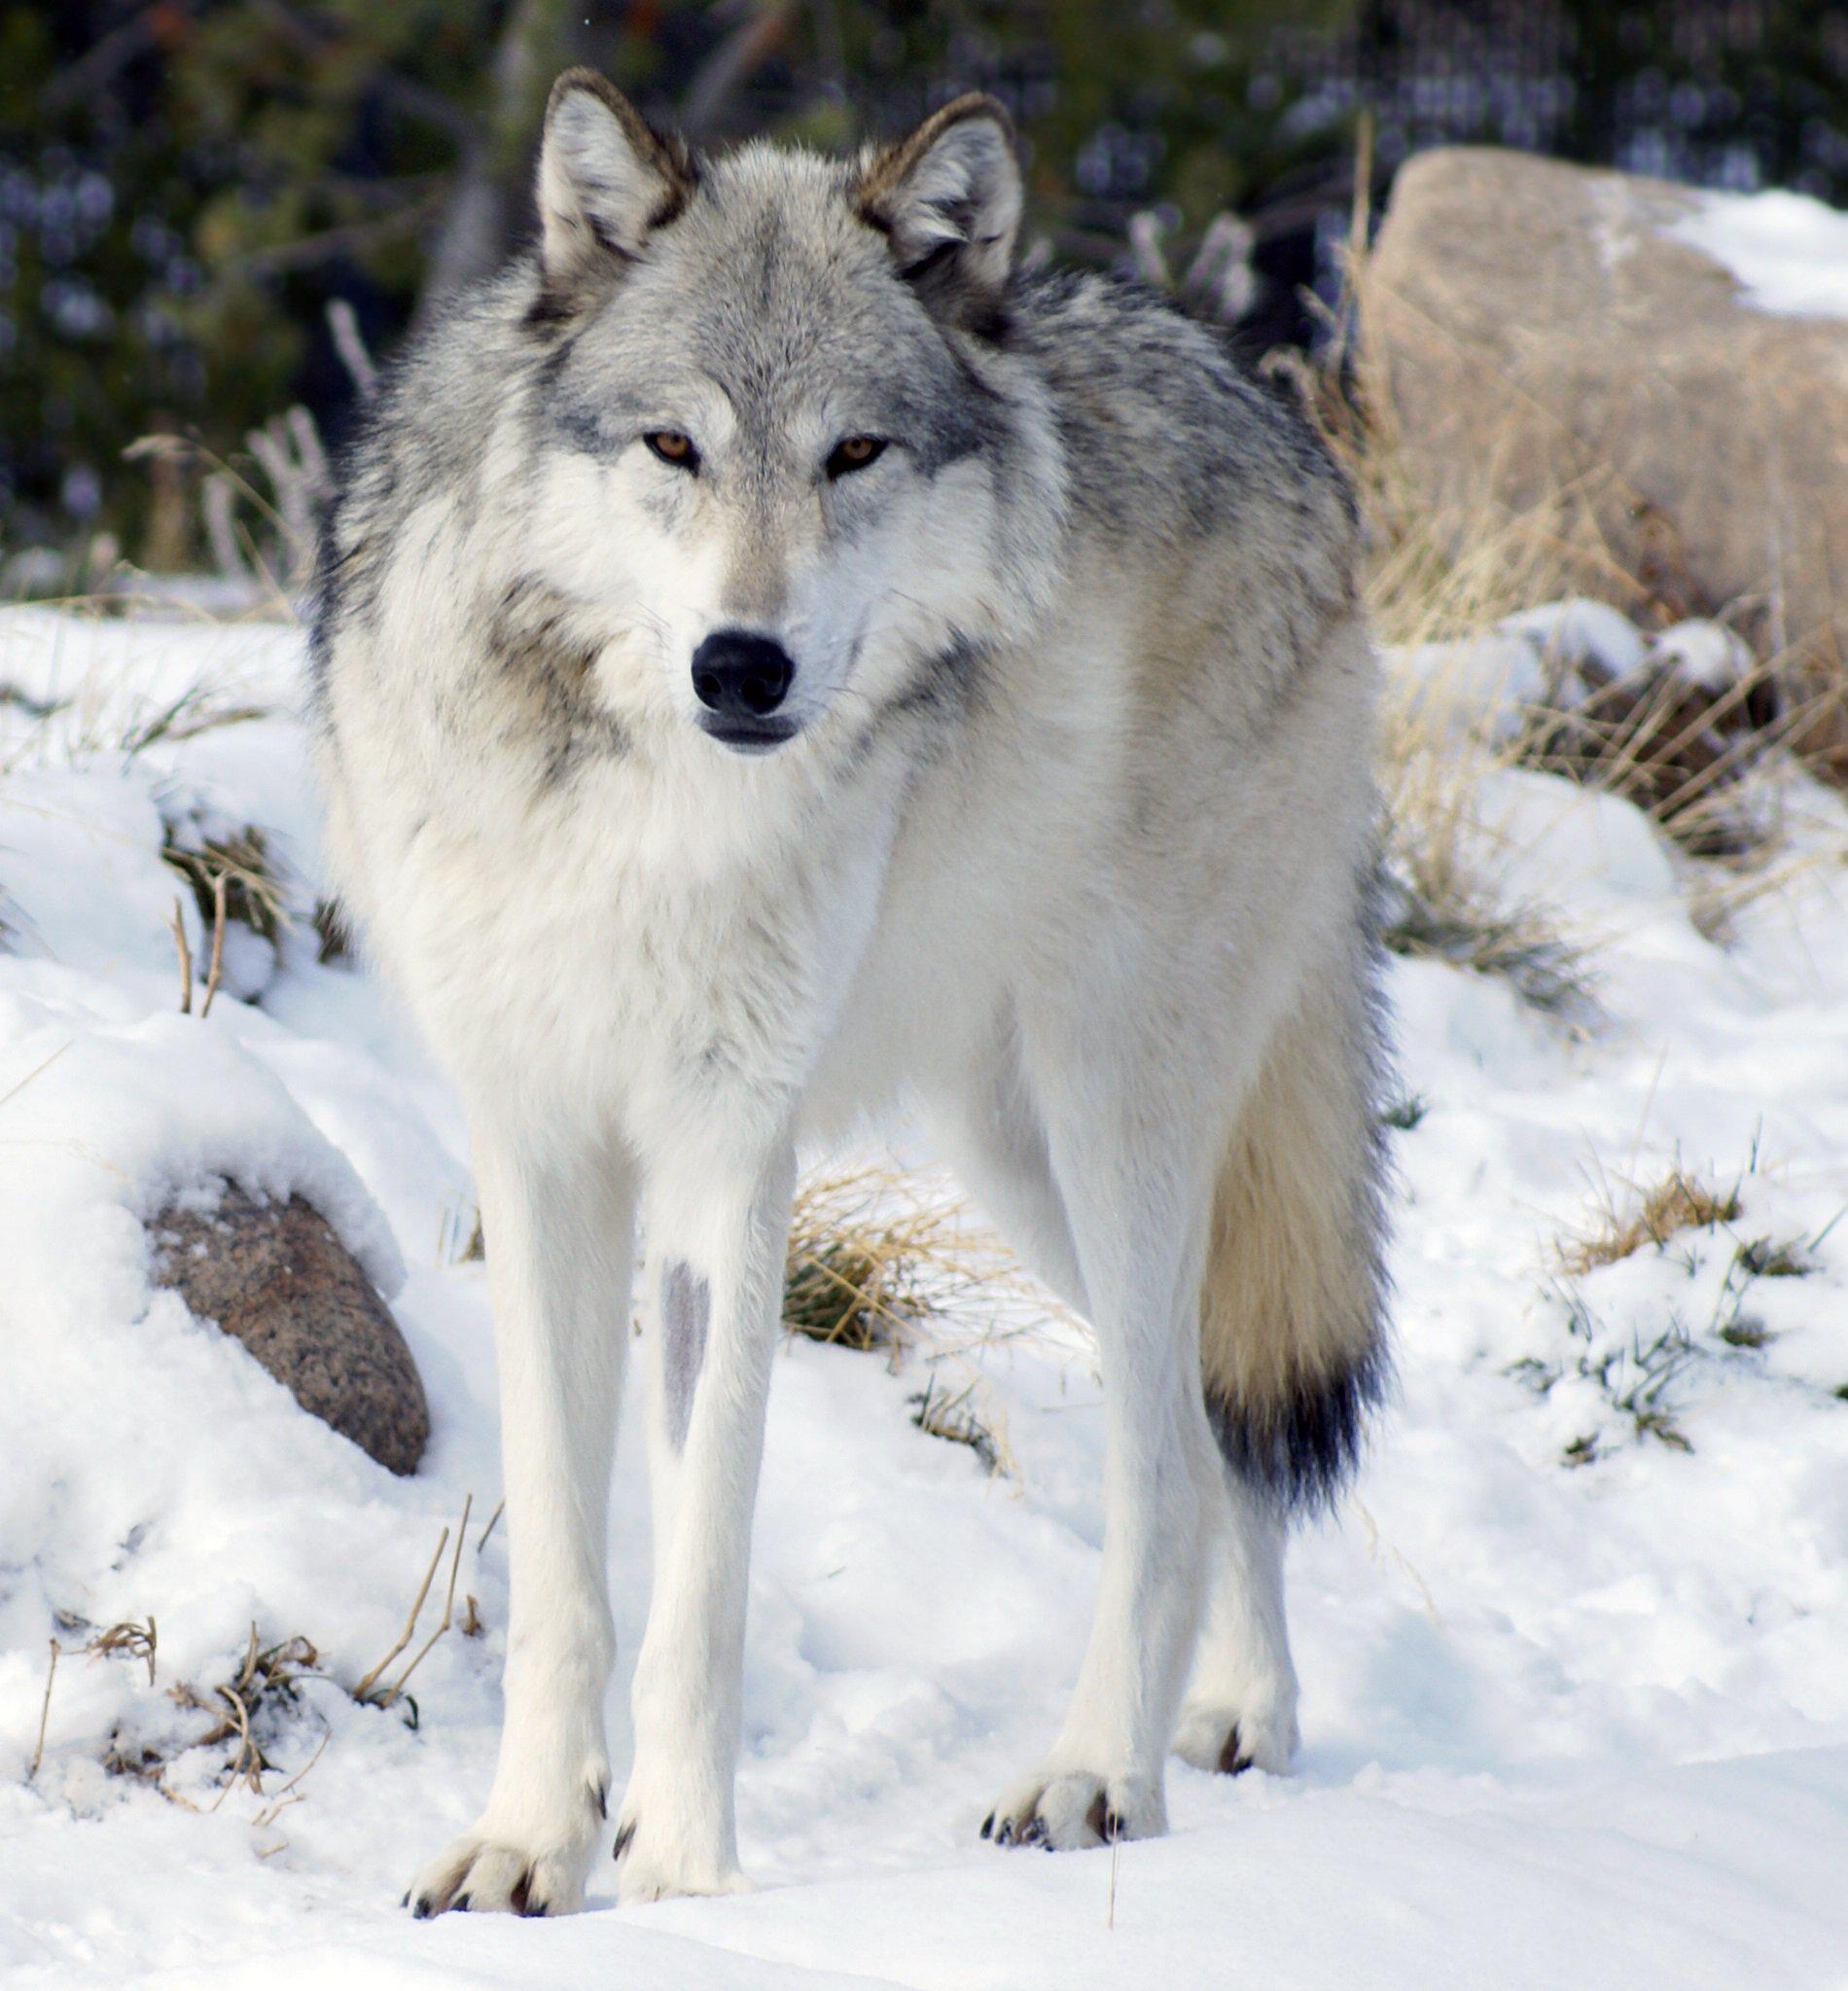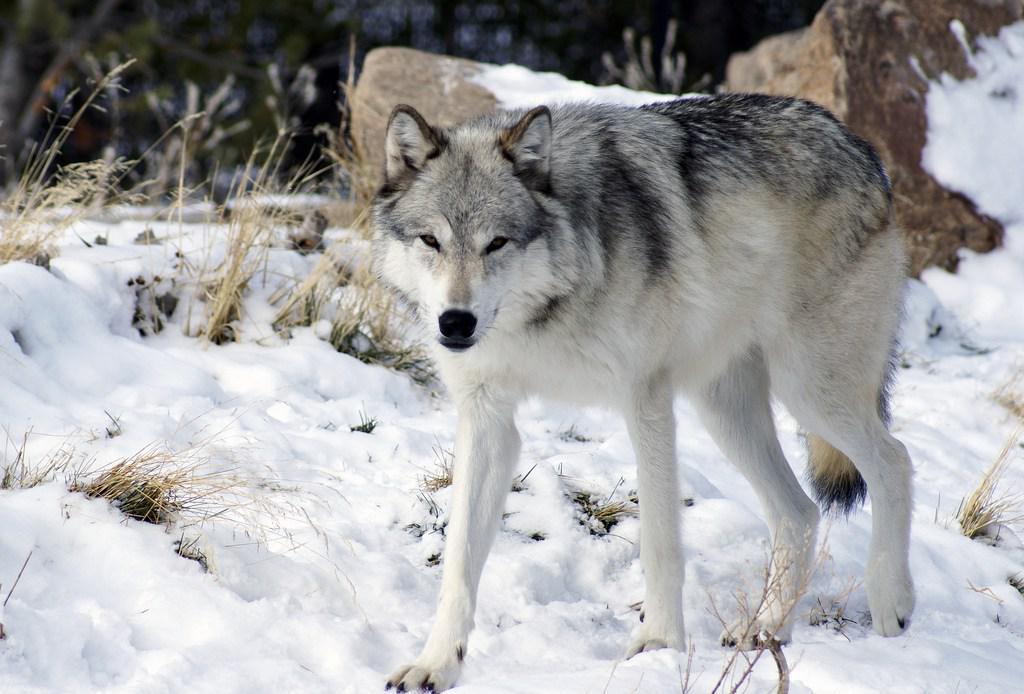The first image is the image on the left, the second image is the image on the right. For the images displayed, is the sentence "A canine can be seen laying on the ground." factually correct? Answer yes or no. No. The first image is the image on the left, the second image is the image on the right. Analyze the images presented: Is the assertion "An animal is laying down." valid? Answer yes or no. No. 